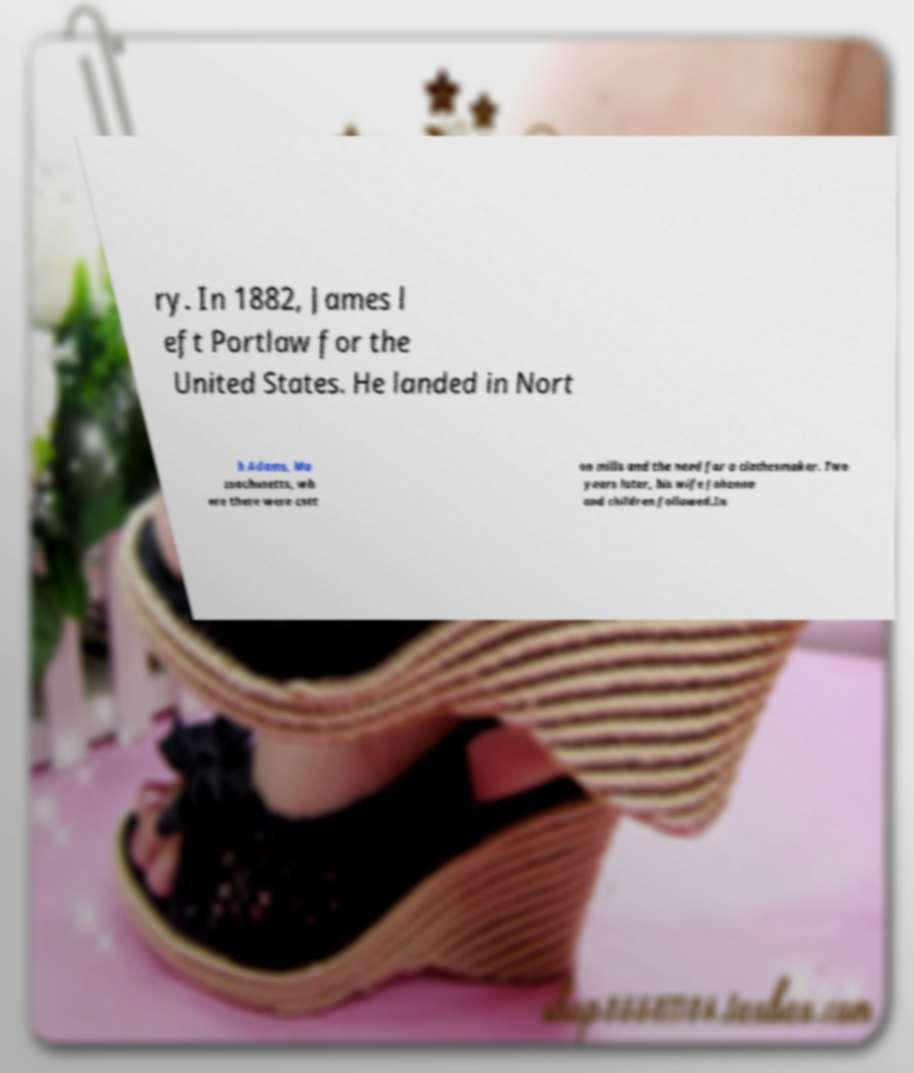Can you read and provide the text displayed in the image?This photo seems to have some interesting text. Can you extract and type it out for me? ry. In 1882, James l eft Portlaw for the United States. He landed in Nort h Adams, Ma ssachusetts, wh ere there were cott on mills and the need for a clothesmaker. Two years later, his wife Johanna and children followed.In 